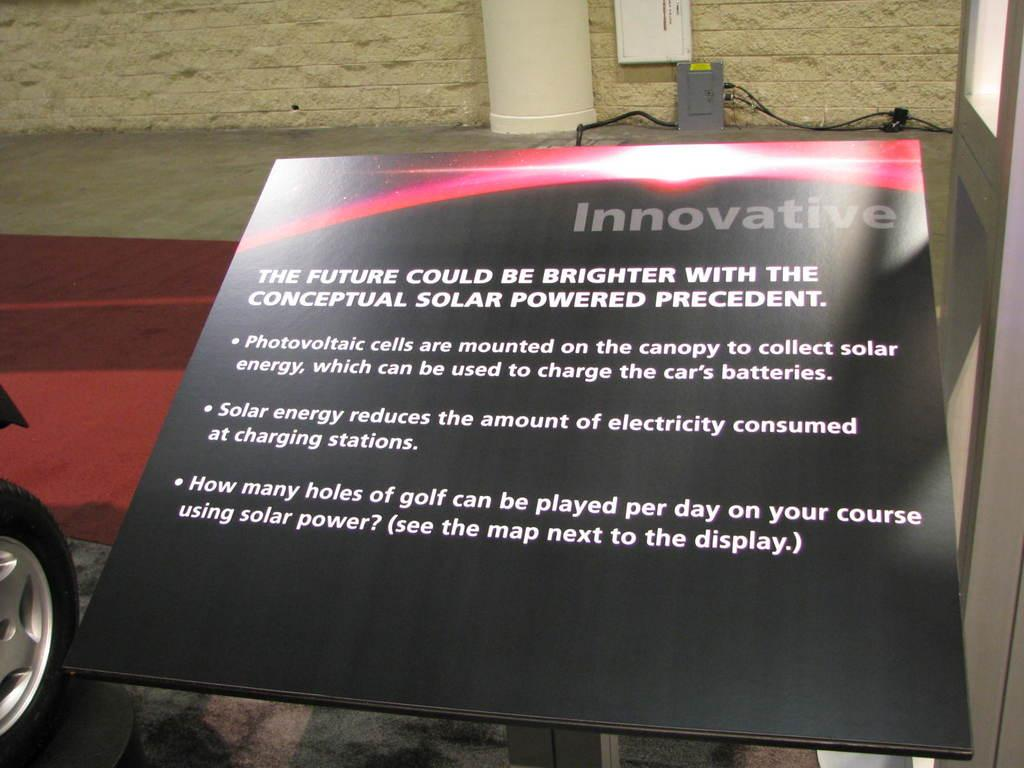What is located in the foreground of the image? There is a board with text in the foreground of the image. What can be seen on the left side of the image? There is a vehicle tire on the left side of the image. What is visible in the background of the image? There is a wall in the background of the image. Can you tell me how many stems are growing from the wall in the image? There are no stems growing from the wall in the image; it is a plain wall. Is there a boat visible in the image? No, there is no boat present in the image. 